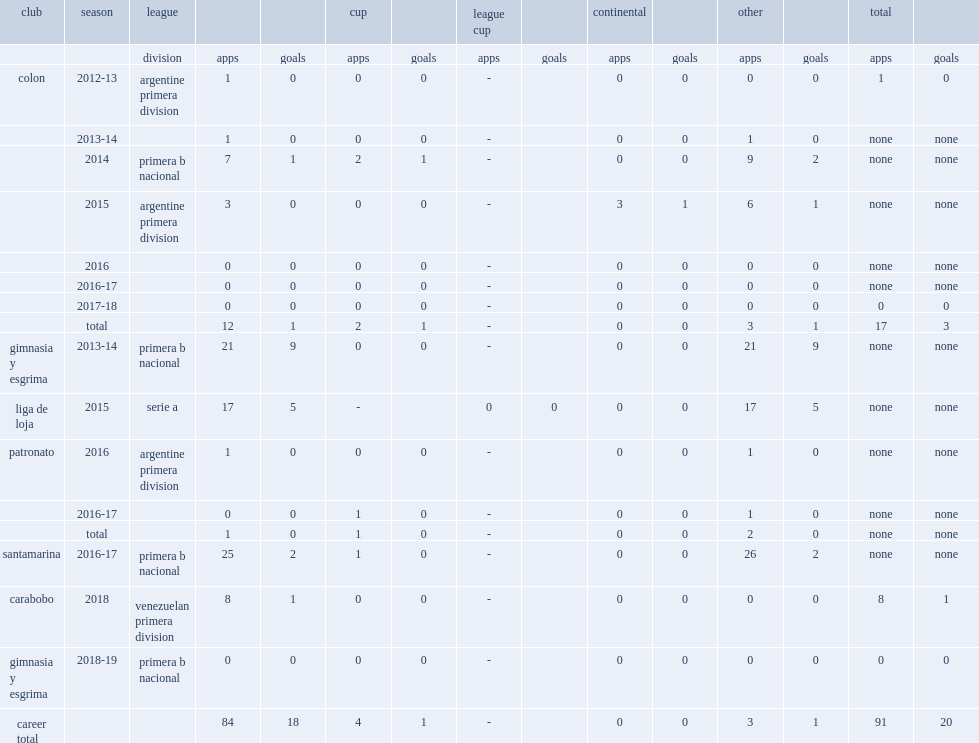Which club did callejo play for in 2016? Patronato. 